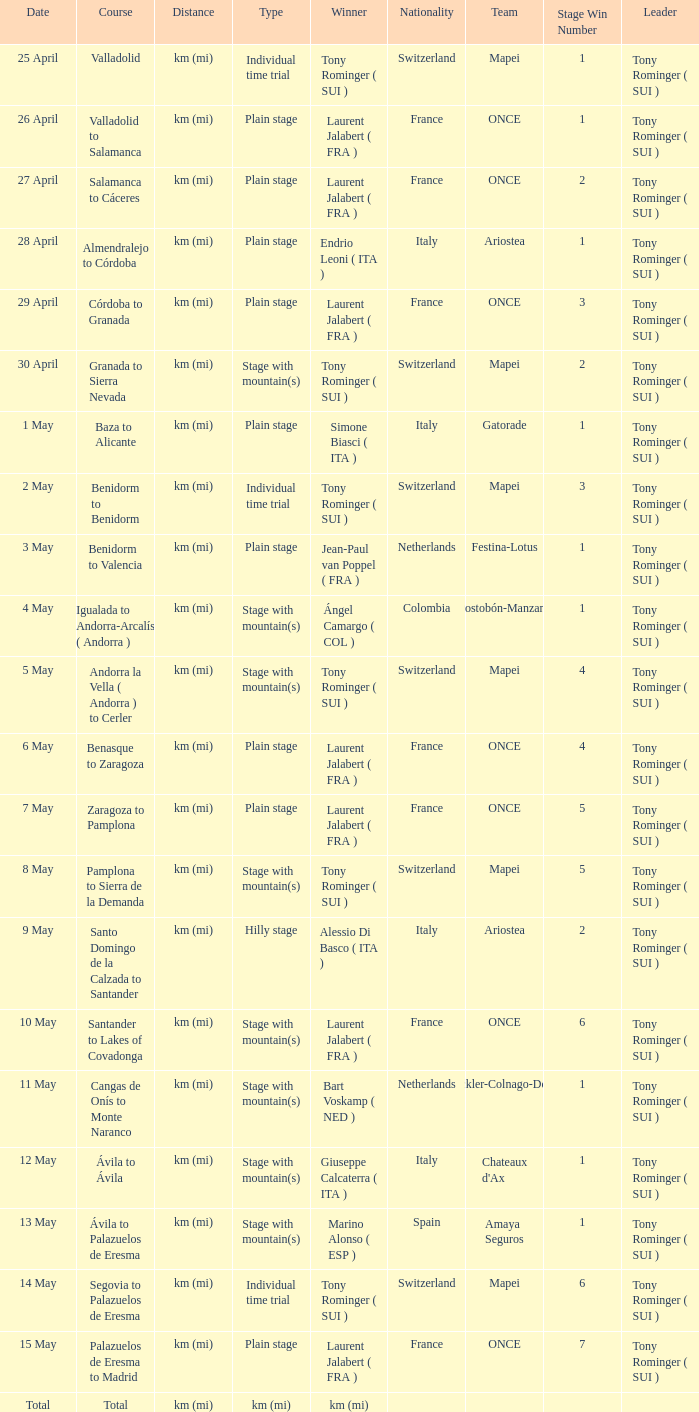What was the date with a winner of km (mi)? Total. 